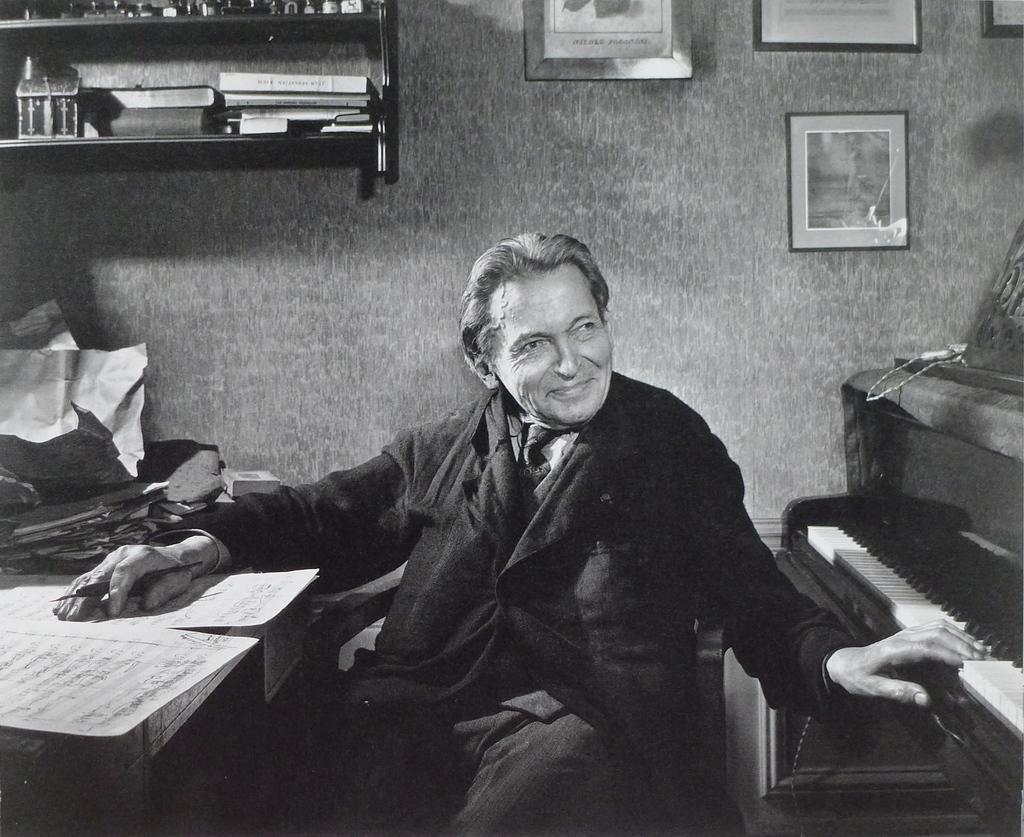Describe this image in one or two sentences. In this image i can see a man sitting and laughing he is holding a pen there are few papers on a table, at the right side there is a musical instrument, at the back ground i can see few frames attached to a wall and few books on a shelf. 